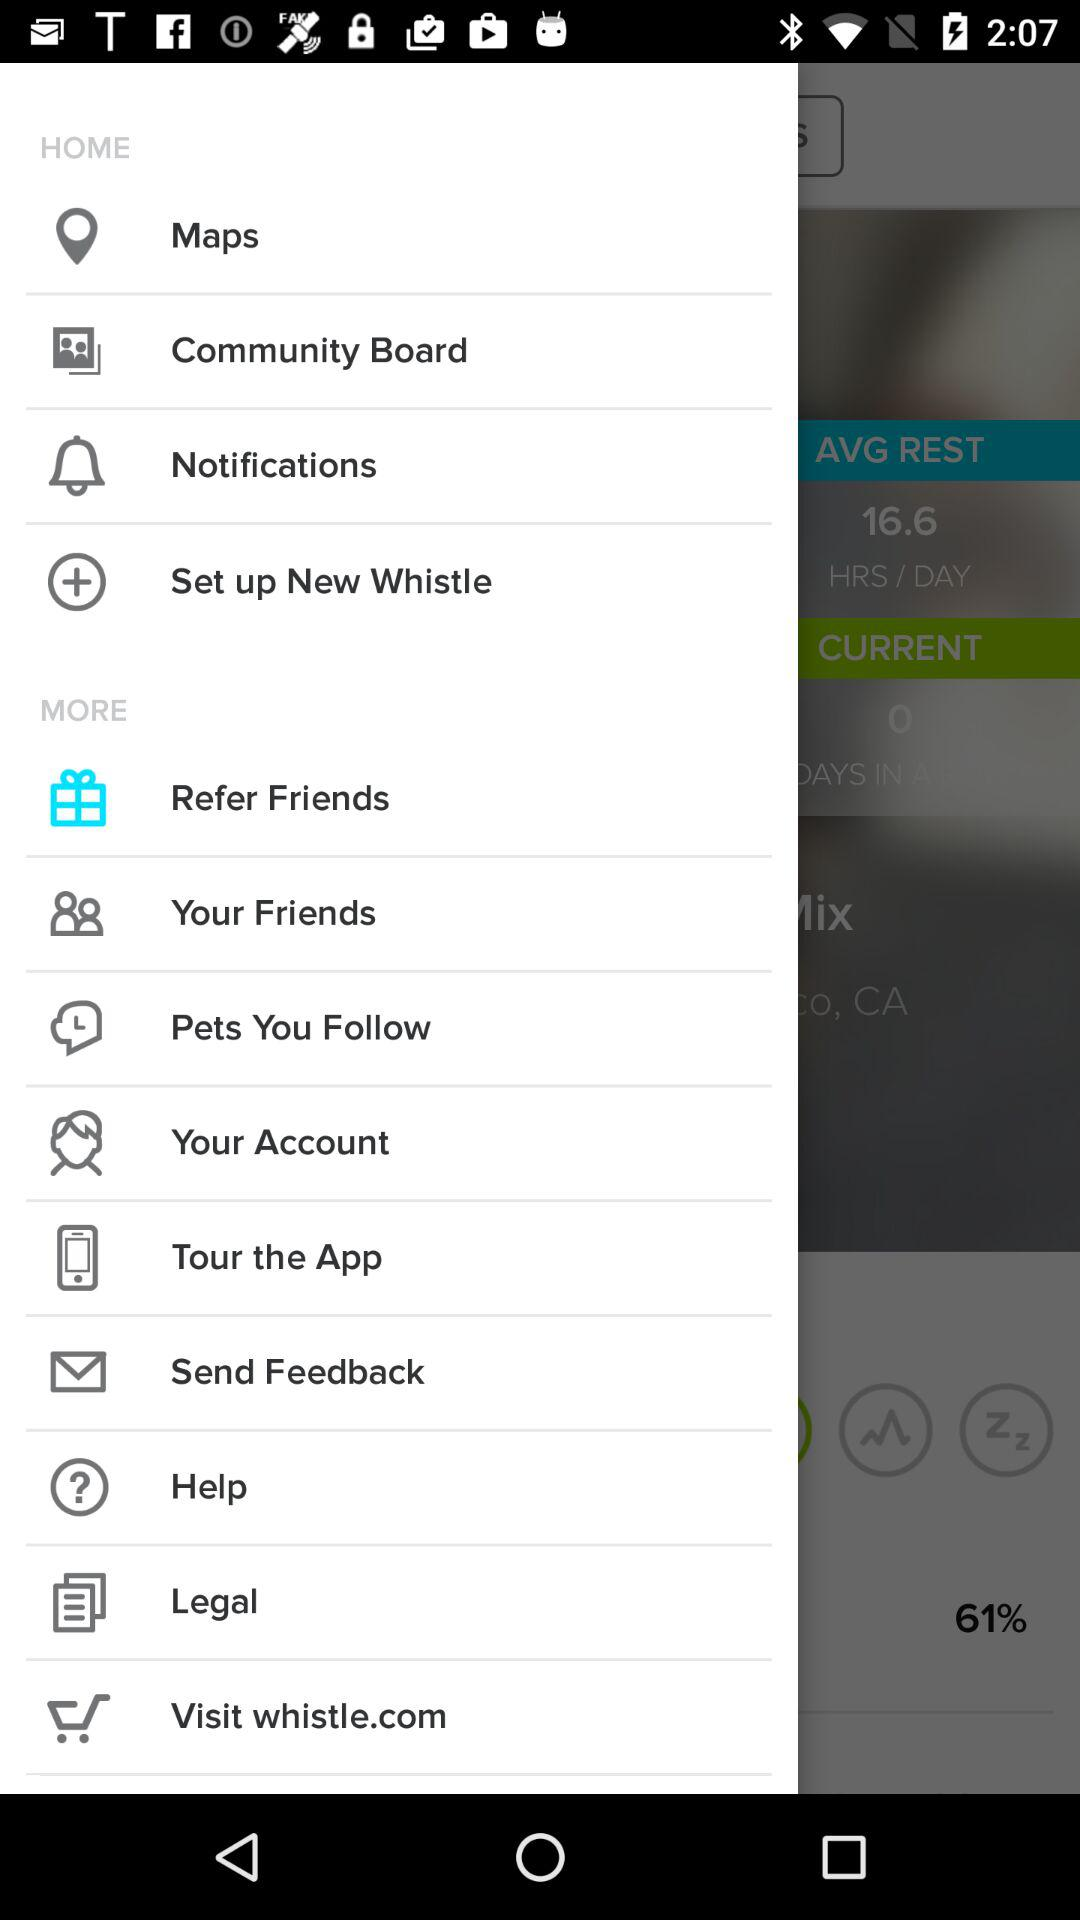What website can I visit? You can visit whistle.com. 